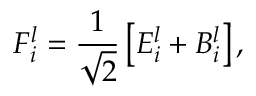Convert formula to latex. <formula><loc_0><loc_0><loc_500><loc_500>F _ { i } ^ { l } = \frac { 1 } { \sqrt { 2 } } \left [ E _ { i } ^ { l } + B _ { i } ^ { l } \right ] ,</formula> 